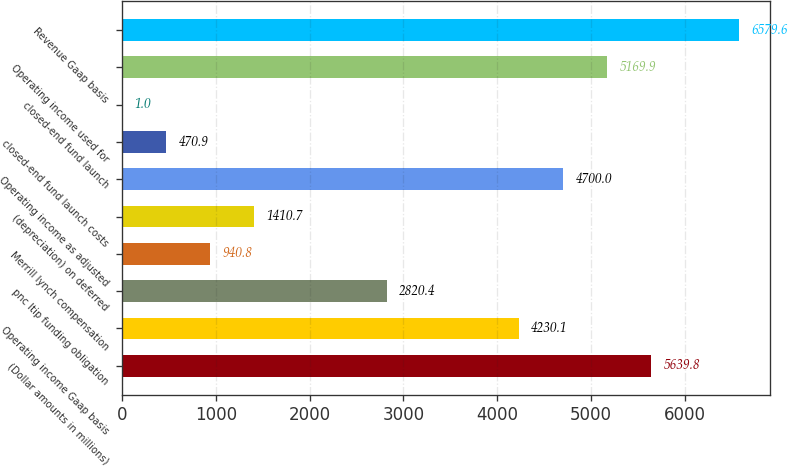<chart> <loc_0><loc_0><loc_500><loc_500><bar_chart><fcel>(Dollar amounts in millions)<fcel>Operating income Gaap basis<fcel>pnc ltip funding obligation<fcel>Merrill lynch compensation<fcel>(depreciation) on deferred<fcel>Operating income as adjusted<fcel>closed-end fund launch costs<fcel>closed-end fund launch<fcel>Operating income used for<fcel>Revenue Gaap basis<nl><fcel>5639.8<fcel>4230.1<fcel>2820.4<fcel>940.8<fcel>1410.7<fcel>4700<fcel>470.9<fcel>1<fcel>5169.9<fcel>6579.6<nl></chart> 